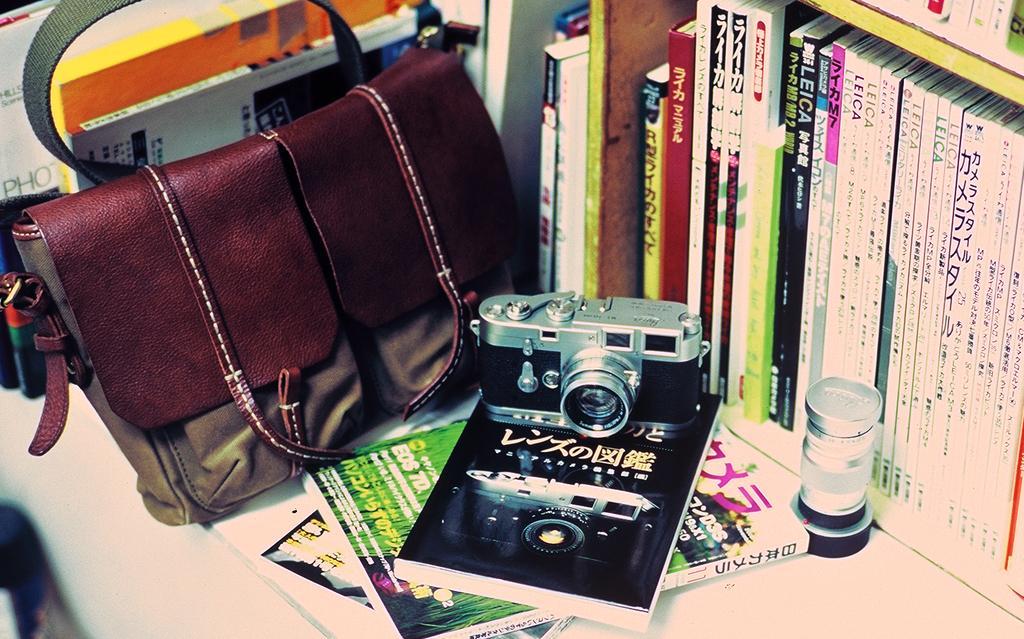Please provide a concise description of this image. In this picture there is a handbag a camera some books arranged in a shelf 